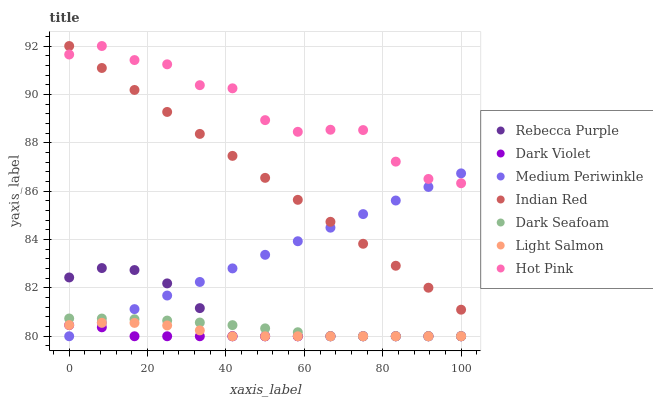Does Dark Violet have the minimum area under the curve?
Answer yes or no. Yes. Does Hot Pink have the maximum area under the curve?
Answer yes or no. Yes. Does Medium Periwinkle have the minimum area under the curve?
Answer yes or no. No. Does Medium Periwinkle have the maximum area under the curve?
Answer yes or no. No. Is Medium Periwinkle the smoothest?
Answer yes or no. Yes. Is Hot Pink the roughest?
Answer yes or no. Yes. Is Hot Pink the smoothest?
Answer yes or no. No. Is Medium Periwinkle the roughest?
Answer yes or no. No. Does Light Salmon have the lowest value?
Answer yes or no. Yes. Does Hot Pink have the lowest value?
Answer yes or no. No. Does Indian Red have the highest value?
Answer yes or no. Yes. Does Medium Periwinkle have the highest value?
Answer yes or no. No. Is Dark Violet less than Hot Pink?
Answer yes or no. Yes. Is Indian Red greater than Dark Violet?
Answer yes or no. Yes. Does Rebecca Purple intersect Light Salmon?
Answer yes or no. Yes. Is Rebecca Purple less than Light Salmon?
Answer yes or no. No. Is Rebecca Purple greater than Light Salmon?
Answer yes or no. No. Does Dark Violet intersect Hot Pink?
Answer yes or no. No. 